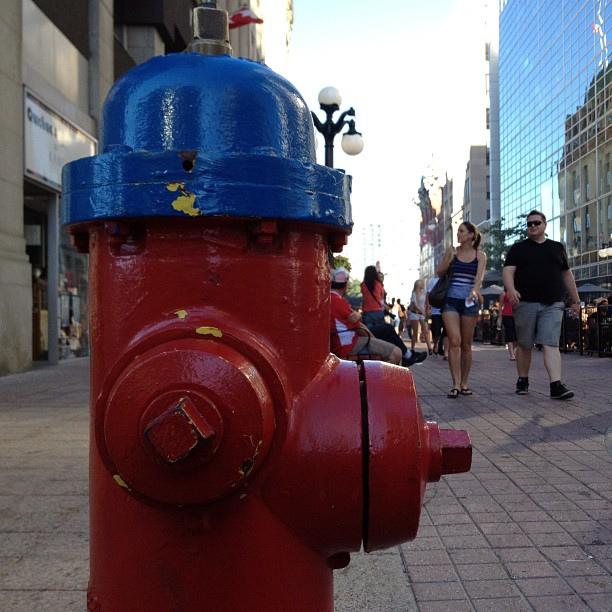Is the fire hydrant all one color?
Answer briefly. No. Are the people wearing shorts?
Answer briefly. Yes. What is the hydrant used for?
Concise answer only. Water. 